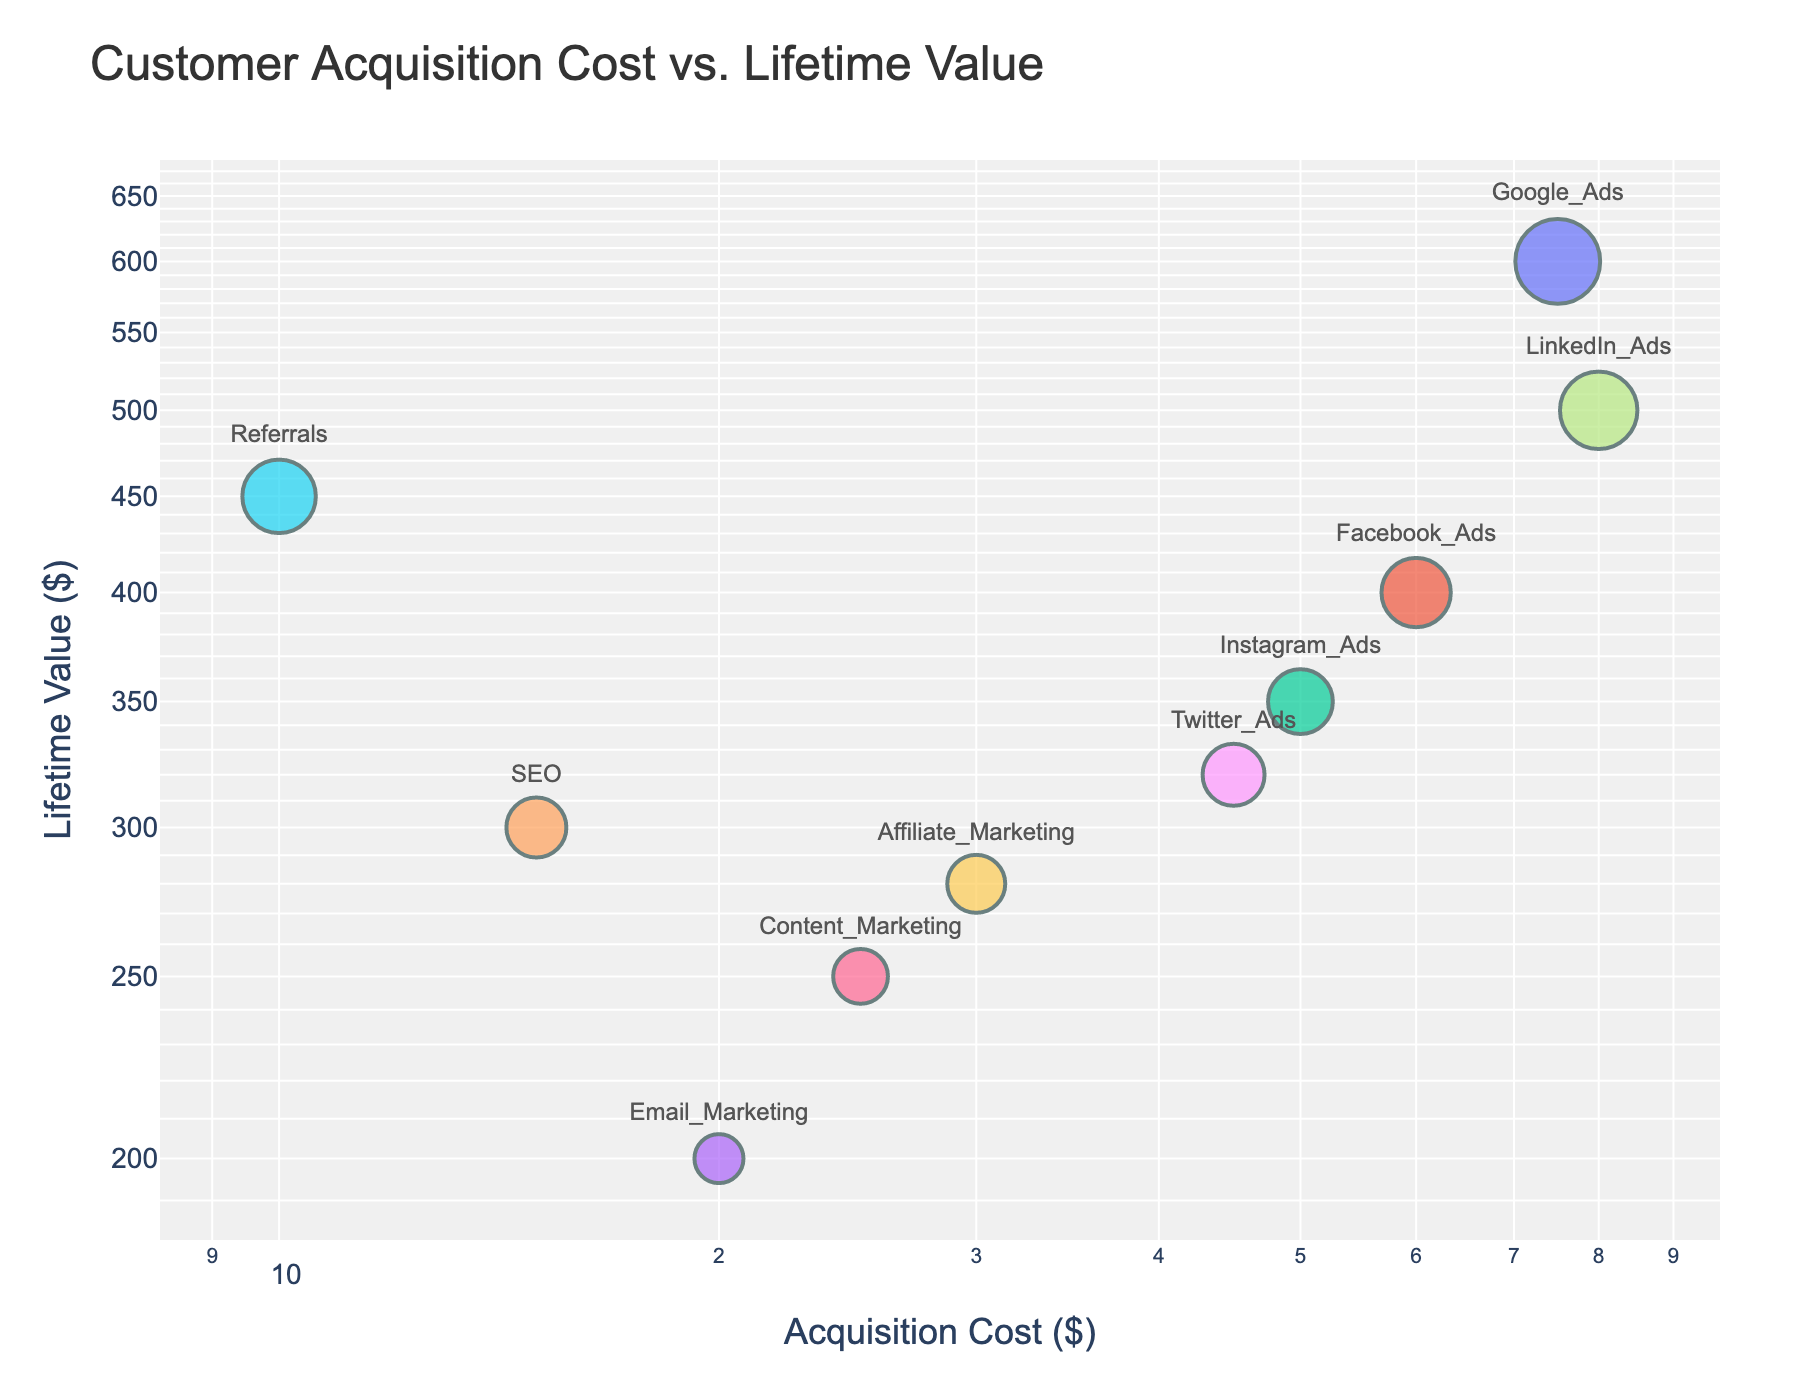Which marketing channel has the highest customer lifetime value? By observing the plot, the data point with the highest y-value represents the highest customer lifetime value. Here, the y-axis is customer lifetime value. "Referrals" is positioned at the highest value (~450) on this axis.
Answer: Referrals What is the relationship between customer acquisition cost and lifetime value for SEO compared to LinkedIn Ads? Looking at the plot, SEO has a lower customer acquisition cost (~15) and a lower lifetime value (~300) compared to LinkedIn Ads, which has a higher customer acquisition cost (~80) and a higher lifetime value (~500). Therefore, SEO is cheaper but results in a lower customer lifetime value, whereas LinkedIn Ads is more expensive but yields a higher lifetime value.
Answer: SEO is cheaper with lower lifetime value, LinkedIn Ads is expensive with higher lifetime value Which marketing channel has the lowest customer acquisition cost, and what is its approximate customer lifetime value? To find the marketing channel with the lowest customer acquisition cost, locate the point closest to the origin on the x-axis. Referrals has the lowest acquisition cost (~10) and a corresponding lifetime value of approximately ~450.
Answer: Referrals, 450 How do Facebook Ads and Instagram Ads compare in terms of customer acquisition cost and lifetime value? Identify the points for Facebook Ads and Instagram Ads on the plot. Facebook Ads has a higher customer acquisition cost (~60) compared to Instagram Ads (~50) but a higher customer lifetime value (~400) compared to Instagram Ads (~350). Therefore, Facebook Ads is more expensive but results in a higher lifetime value than Instagram Ads.
Answer: Facebook Ads is more expensive with higher lifetime value than Instagram Ads Which marketing channel offers the highest customer lifetime value relative to its acquisition cost? To determine this, we can estimate the ratio of customer lifetime value to acquisition cost for each channel by examining both axes. Referrals stands out with the highest lifetime value (~450) and the lowest acquisition cost (~10), providing the highest lifetime value relative to its acquisition cost.
Answer: Referrals If you combine the customer acquisition cost for Google Ads and LinkedIn Ads, how does their combined cost compare to the acquisition cost of Twitter Ads? Sum the acquisition costs for Google Ads (75) and LinkedIn Ads (80), which equals 155. Compare this to the acquisition cost of Twitter Ads (45). The combined cost is significantly higher than the single cost of Twitter Ads.
Answer: Combined cost is 110 more than Twitter Ads What is the range of customer acquisition costs in the chart? To find the range, identify the minimum and maximum x-values, which are ~10 (Referrals) and ~80 (LinkedIn Ads). Subtract the minimum cost from the maximum cost: 80 - 10 = 70.
Answer: 70 How does the lifetime value of Twitter Ads compare to Content Marketing? Identify the points for Twitter Ads and Content Marketing. Twitter Ads has a customer lifetime value of approximately ~320, while Content Marketing is around ~250. Therefore, Twitter Ads has a higher customer lifetime value than Content Marketing.
Answer: Twitter Ads has higher lifetime value than Content Marketing Which marketing channels have a customer lifetime value greater than 300? Examine the y-axis for data points above the 300 mark. The channels with a lifetime value greater than 300 are: Google Ads (~600), Facebook Ads (~400), SEO (~300), Referrals (~450), LinkedIn Ads (~500), and Twitter Ads (~320).
Answer: Google Ads, Facebook Ads, SEO, Referrals, LinkedIn Ads, Twitter Ads Is there a general trend between customer acquisition cost and customer lifetime value in the plot? The scatter plot shows a log-log scale. In general, there seems to be a positive trend where higher customer acquisition costs are associated with higher customer lifetime values, though there are some exceptions.
Answer: Higher cost often leads to higher value 